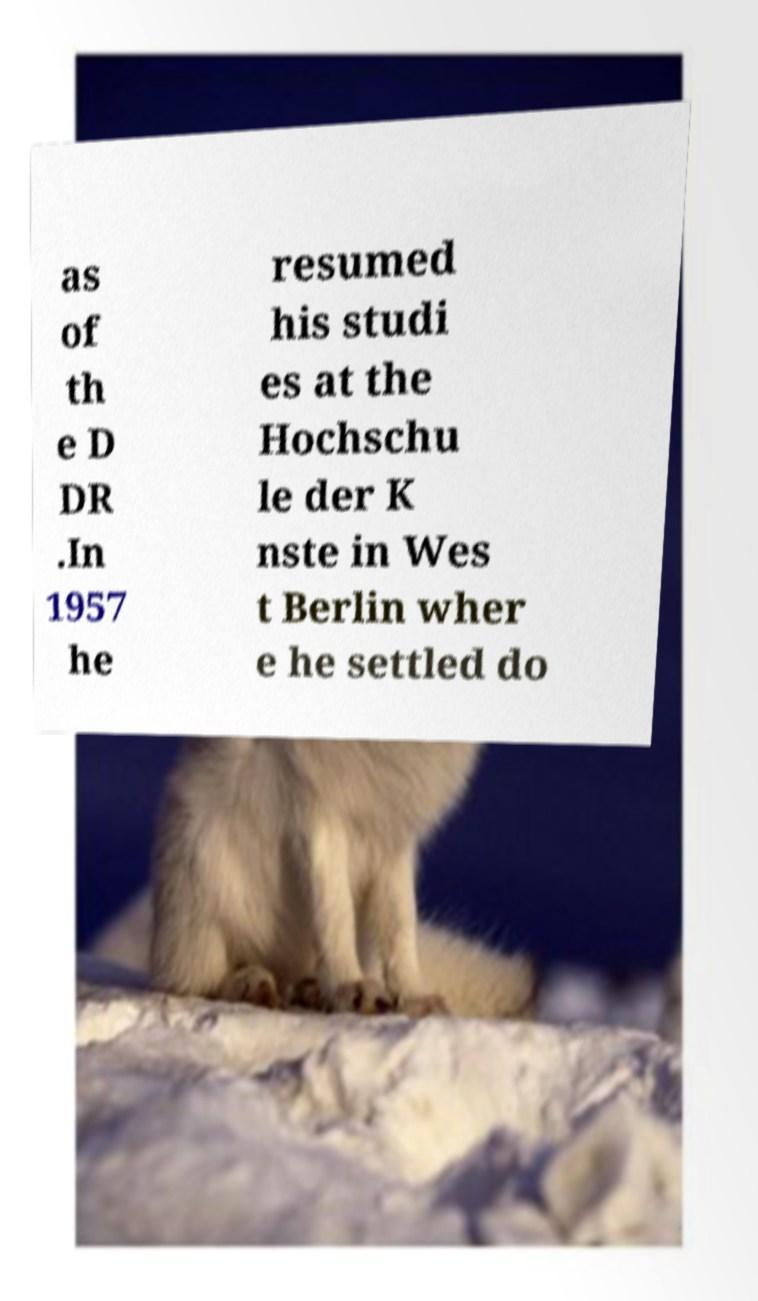There's text embedded in this image that I need extracted. Can you transcribe it verbatim? as of th e D DR .In 1957 he resumed his studi es at the Hochschu le der K nste in Wes t Berlin wher e he settled do 